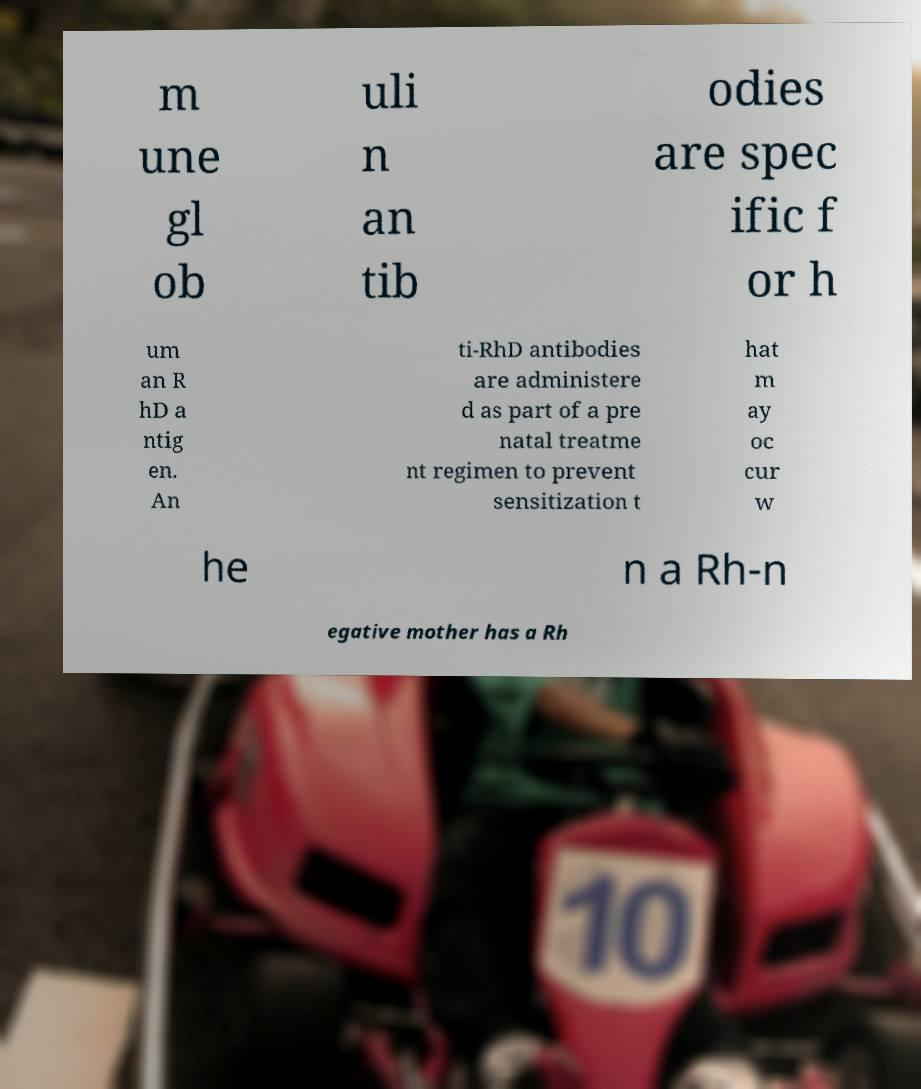What messages or text are displayed in this image? I need them in a readable, typed format. m une gl ob uli n an tib odies are spec ific f or h um an R hD a ntig en. An ti-RhD antibodies are administere d as part of a pre natal treatme nt regimen to prevent sensitization t hat m ay oc cur w he n a Rh-n egative mother has a Rh 